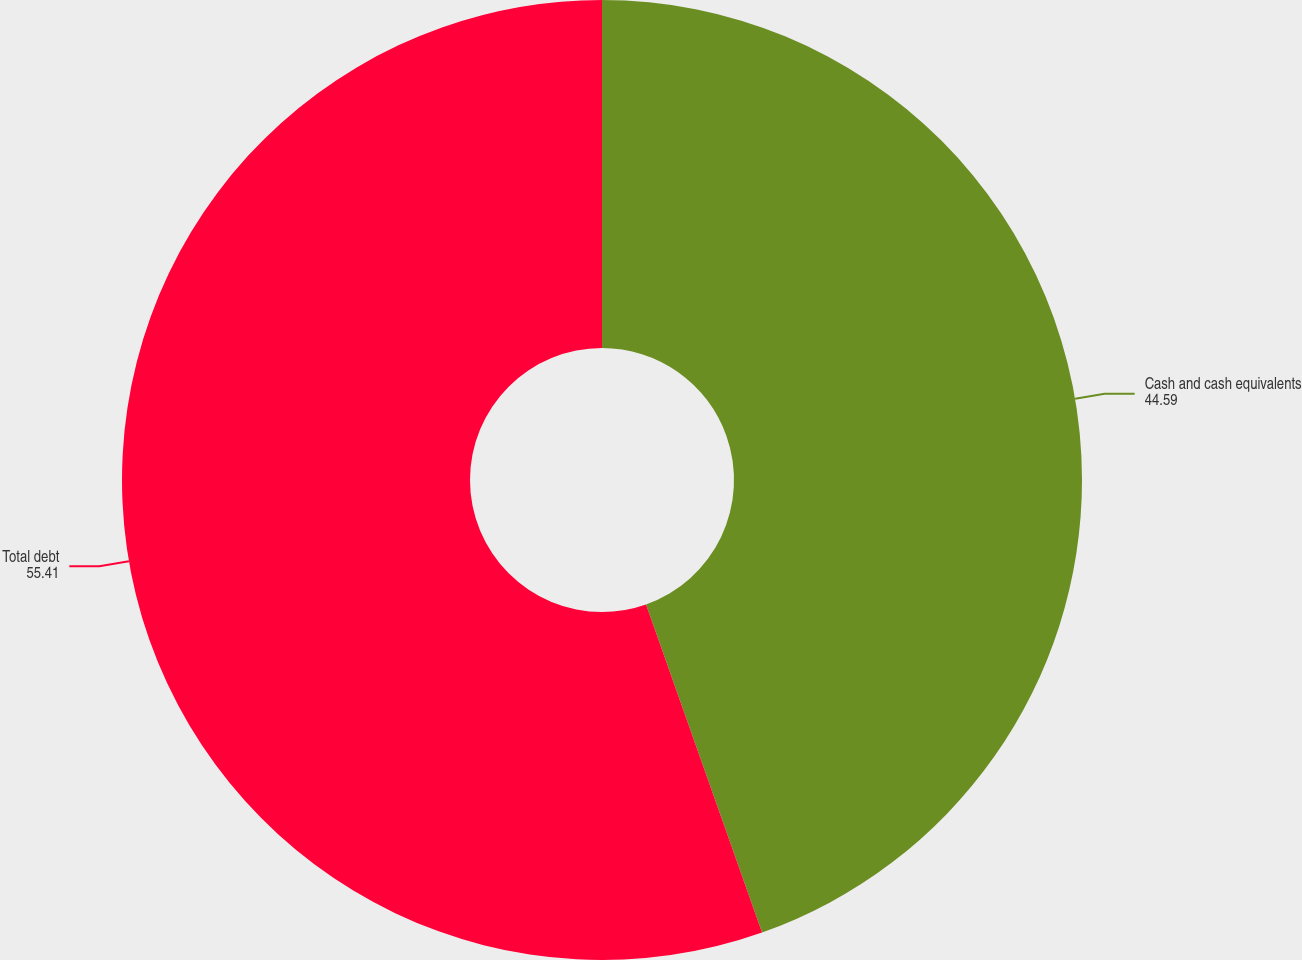Convert chart. <chart><loc_0><loc_0><loc_500><loc_500><pie_chart><fcel>Cash and cash equivalents<fcel>Total debt<nl><fcel>44.59%<fcel>55.41%<nl></chart> 